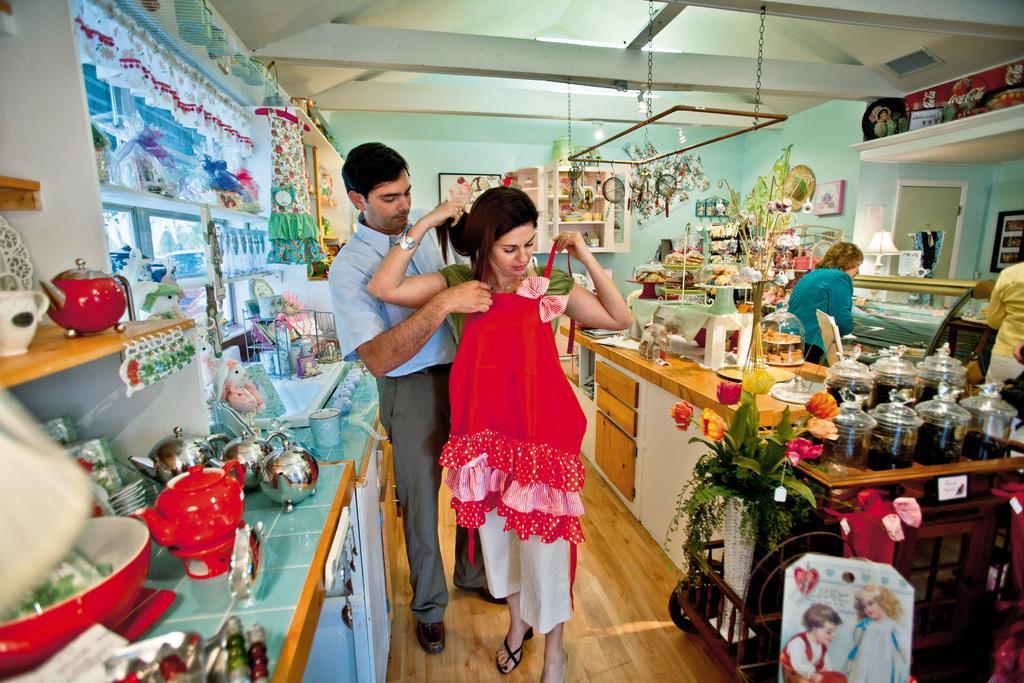Please provide a concise description of this image. In this picture there is a woman who is wearing green shirt, white trouser and sandal. Beside her there is a man who is holding the red dress. On the right there is a woman who is standing near to the table. On the table I can see the kitchen appliance. 